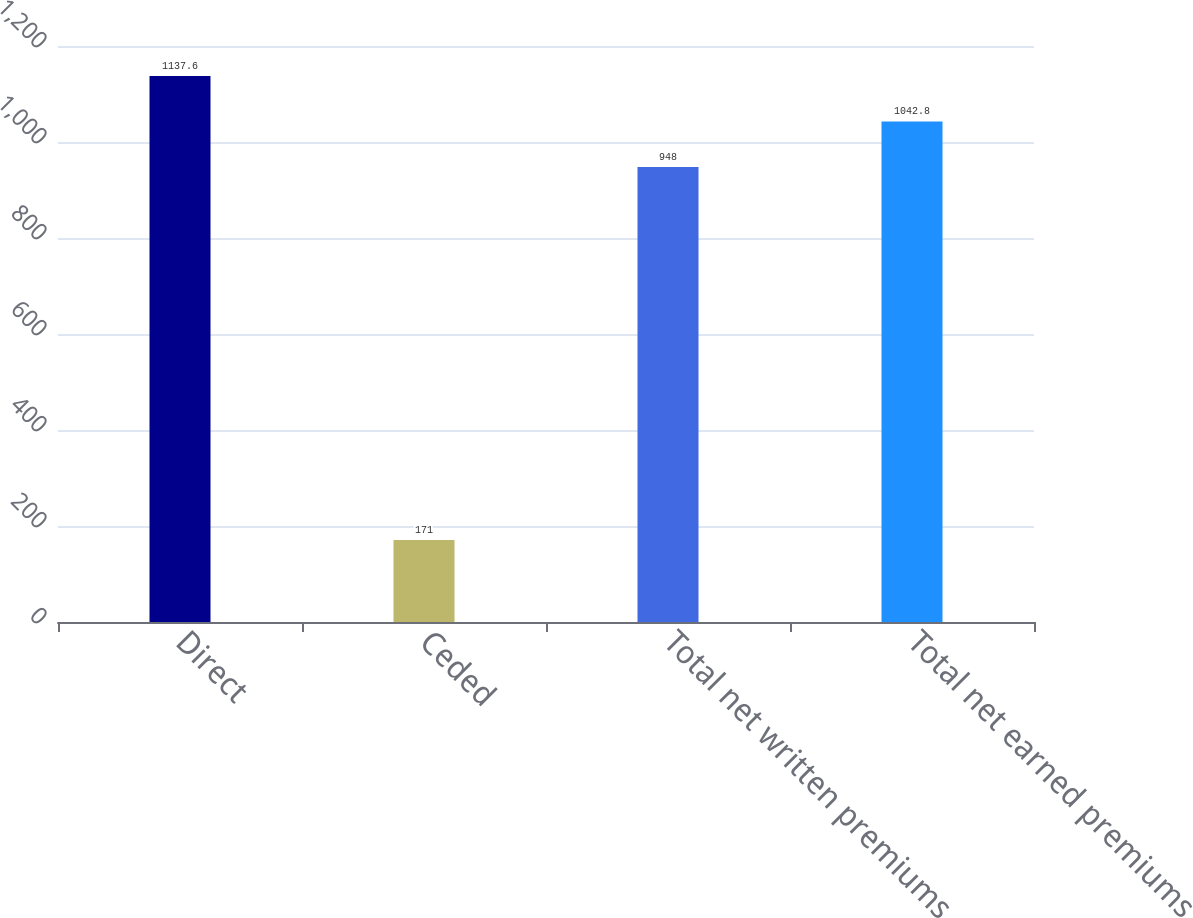Convert chart. <chart><loc_0><loc_0><loc_500><loc_500><bar_chart><fcel>Direct<fcel>Ceded<fcel>Total net written premiums<fcel>Total net earned premiums<nl><fcel>1137.6<fcel>171<fcel>948<fcel>1042.8<nl></chart> 